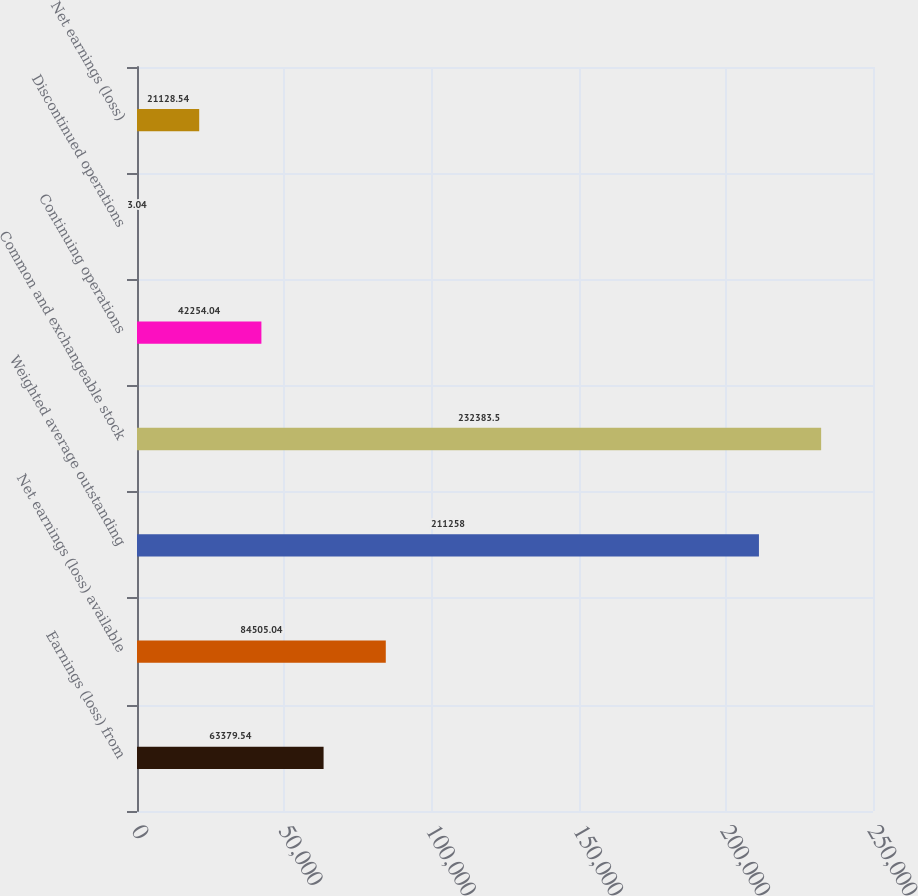<chart> <loc_0><loc_0><loc_500><loc_500><bar_chart><fcel>Earnings (loss) from<fcel>Net earnings (loss) available<fcel>Weighted average outstanding<fcel>Common and exchangeable stock<fcel>Continuing operations<fcel>Discontinued operations<fcel>Net earnings (loss)<nl><fcel>63379.5<fcel>84505<fcel>211258<fcel>232384<fcel>42254<fcel>3.04<fcel>21128.5<nl></chart> 